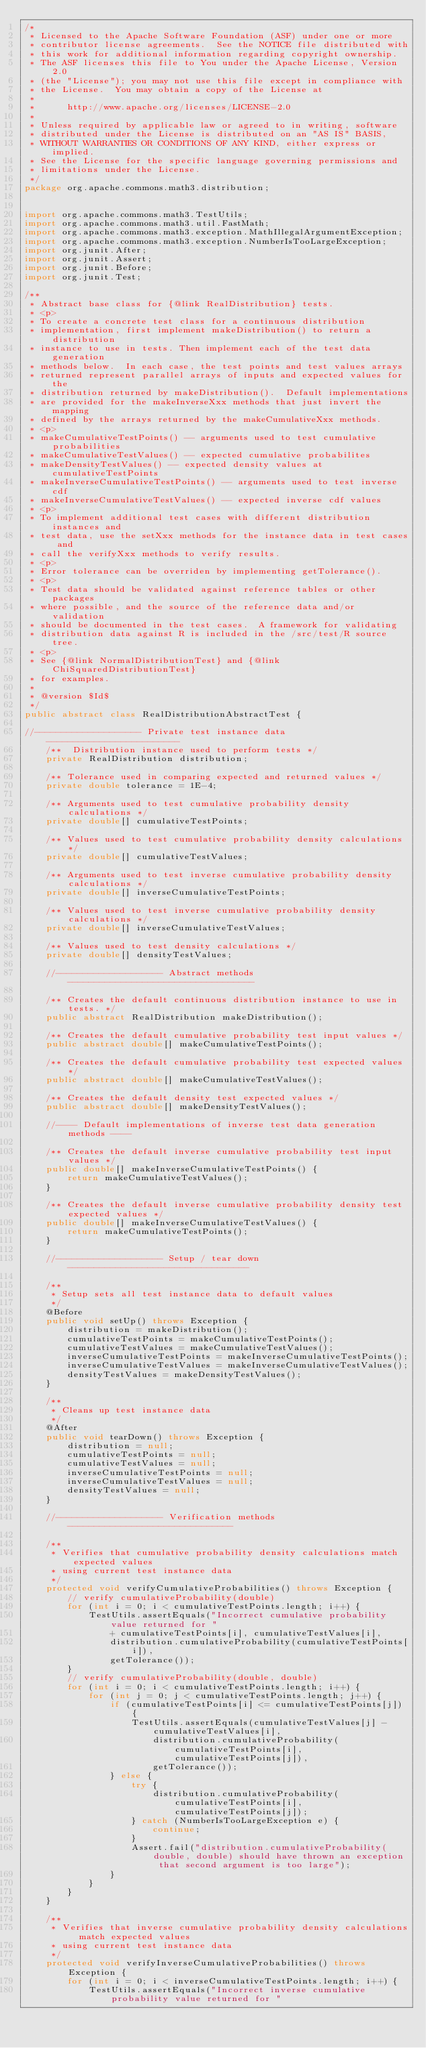<code> <loc_0><loc_0><loc_500><loc_500><_Java_>/*
 * Licensed to the Apache Software Foundation (ASF) under one or more
 * contributor license agreements.  See the NOTICE file distributed with
 * this work for additional information regarding copyright ownership.
 * The ASF licenses this file to You under the Apache License, Version 2.0
 * (the "License"); you may not use this file except in compliance with
 * the License.  You may obtain a copy of the License at
 *
 *      http://www.apache.org/licenses/LICENSE-2.0
 *
 * Unless required by applicable law or agreed to in writing, software
 * distributed under the License is distributed on an "AS IS" BASIS,
 * WITHOUT WARRANTIES OR CONDITIONS OF ANY KIND, either express or implied.
 * See the License for the specific language governing permissions and
 * limitations under the License.
 */
package org.apache.commons.math3.distribution;


import org.apache.commons.math3.TestUtils;
import org.apache.commons.math3.util.FastMath;
import org.apache.commons.math3.exception.MathIllegalArgumentException;
import org.apache.commons.math3.exception.NumberIsTooLargeException;
import org.junit.After;
import org.junit.Assert;
import org.junit.Before;
import org.junit.Test;

/**
 * Abstract base class for {@link RealDistribution} tests.
 * <p>
 * To create a concrete test class for a continuous distribution
 * implementation, first implement makeDistribution() to return a distribution
 * instance to use in tests. Then implement each of the test data generation
 * methods below.  In each case, the test points and test values arrays
 * returned represent parallel arrays of inputs and expected values for the
 * distribution returned by makeDistribution().  Default implementations
 * are provided for the makeInverseXxx methods that just invert the mapping
 * defined by the arrays returned by the makeCumulativeXxx methods.
 * <p>
 * makeCumulativeTestPoints() -- arguments used to test cumulative probabilities
 * makeCumulativeTestValues() -- expected cumulative probabilites
 * makeDensityTestValues() -- expected density values at cumulativeTestPoints
 * makeInverseCumulativeTestPoints() -- arguments used to test inverse cdf
 * makeInverseCumulativeTestValues() -- expected inverse cdf values
 * <p>
 * To implement additional test cases with different distribution instances and
 * test data, use the setXxx methods for the instance data in test cases and
 * call the verifyXxx methods to verify results.
 * <p>
 * Error tolerance can be overriden by implementing getTolerance().
 * <p>
 * Test data should be validated against reference tables or other packages
 * where possible, and the source of the reference data and/or validation
 * should be documented in the test cases.  A framework for validating
 * distribution data against R is included in the /src/test/R source tree.
 * <p>
 * See {@link NormalDistributionTest} and {@link ChiSquaredDistributionTest}
 * for examples.
 *
 * @version $Id$
 */
public abstract class RealDistributionAbstractTest {

//-------------------- Private test instance data -------------------------
    /**  Distribution instance used to perform tests */
    private RealDistribution distribution;

    /** Tolerance used in comparing expected and returned values */
    private double tolerance = 1E-4;

    /** Arguments used to test cumulative probability density calculations */
    private double[] cumulativeTestPoints;

    /** Values used to test cumulative probability density calculations */
    private double[] cumulativeTestValues;

    /** Arguments used to test inverse cumulative probability density calculations */
    private double[] inverseCumulativeTestPoints;

    /** Values used to test inverse cumulative probability density calculations */
    private double[] inverseCumulativeTestValues;

    /** Values used to test density calculations */
    private double[] densityTestValues;

    //-------------------- Abstract methods -----------------------------------

    /** Creates the default continuous distribution instance to use in tests. */
    public abstract RealDistribution makeDistribution();

    /** Creates the default cumulative probability test input values */
    public abstract double[] makeCumulativeTestPoints();

    /** Creates the default cumulative probability test expected values */
    public abstract double[] makeCumulativeTestValues();

    /** Creates the default density test expected values */
    public abstract double[] makeDensityTestValues();

    //---- Default implementations of inverse test data generation methods ----

    /** Creates the default inverse cumulative probability test input values */
    public double[] makeInverseCumulativeTestPoints() {
        return makeCumulativeTestValues();
    }

    /** Creates the default inverse cumulative probability density test expected values */
    public double[] makeInverseCumulativeTestValues() {
        return makeCumulativeTestPoints();
    }

    //-------------------- Setup / tear down ----------------------------------

    /**
     * Setup sets all test instance data to default values
     */
    @Before
    public void setUp() throws Exception {
        distribution = makeDistribution();
        cumulativeTestPoints = makeCumulativeTestPoints();
        cumulativeTestValues = makeCumulativeTestValues();
        inverseCumulativeTestPoints = makeInverseCumulativeTestPoints();
        inverseCumulativeTestValues = makeInverseCumulativeTestValues();
        densityTestValues = makeDensityTestValues();
    }

    /**
     * Cleans up test instance data
     */
    @After
    public void tearDown() throws Exception {
        distribution = null;
        cumulativeTestPoints = null;
        cumulativeTestValues = null;
        inverseCumulativeTestPoints = null;
        inverseCumulativeTestValues = null;
        densityTestValues = null;
    }

    //-------------------- Verification methods -------------------------------

    /**
     * Verifies that cumulative probability density calculations match expected values
     * using current test instance data
     */
    protected void verifyCumulativeProbabilities() throws Exception {
        // verify cumulativeProbability(double)
        for (int i = 0; i < cumulativeTestPoints.length; i++) {
            TestUtils.assertEquals("Incorrect cumulative probability value returned for "
                + cumulativeTestPoints[i], cumulativeTestValues[i],
                distribution.cumulativeProbability(cumulativeTestPoints[i]),
                getTolerance());
        }
        // verify cumulativeProbability(double, double)
        for (int i = 0; i < cumulativeTestPoints.length; i++) {
            for (int j = 0; j < cumulativeTestPoints.length; j++) {
                if (cumulativeTestPoints[i] <= cumulativeTestPoints[j]) {
                    TestUtils.assertEquals(cumulativeTestValues[j] - cumulativeTestValues[i],
                        distribution.cumulativeProbability(cumulativeTestPoints[i], cumulativeTestPoints[j]),
                        getTolerance());
                } else {
                    try {
                        distribution.cumulativeProbability(cumulativeTestPoints[i], cumulativeTestPoints[j]);
                    } catch (NumberIsTooLargeException e) {
                        continue;
                    }
                    Assert.fail("distribution.cumulativeProbability(double, double) should have thrown an exception that second argument is too large");
                }
            }
        }
    }

    /**
     * Verifies that inverse cumulative probability density calculations match expected values
     * using current test instance data
     */
    protected void verifyInverseCumulativeProbabilities() throws Exception {
        for (int i = 0; i < inverseCumulativeTestPoints.length; i++) {
            TestUtils.assertEquals("Incorrect inverse cumulative probability value returned for "</code> 